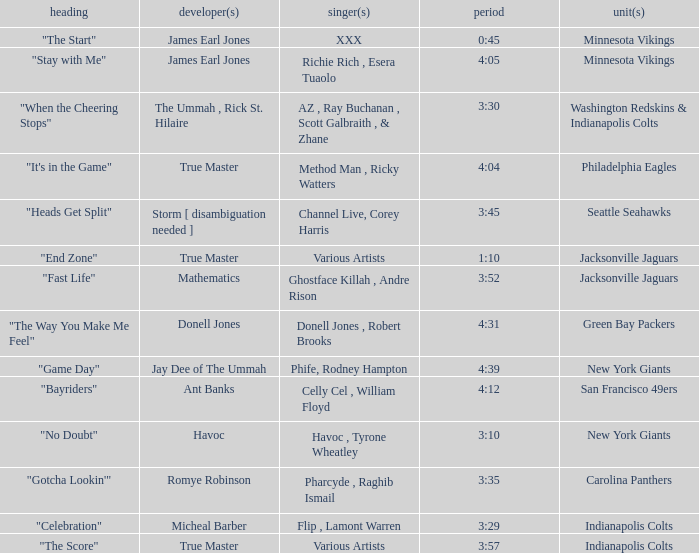What teams used a track 3:29 long? Indianapolis Colts. 